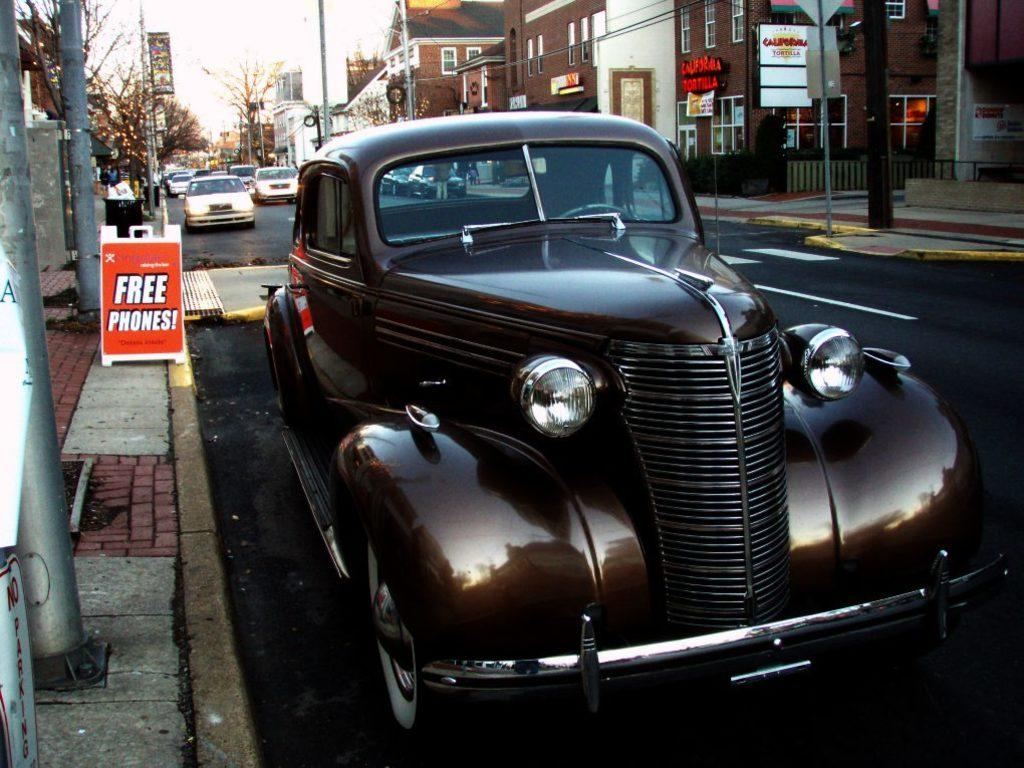<image>
Relay a brief, clear account of the picture shown. A sign in orange states Free phones, beside an unusual old car. 